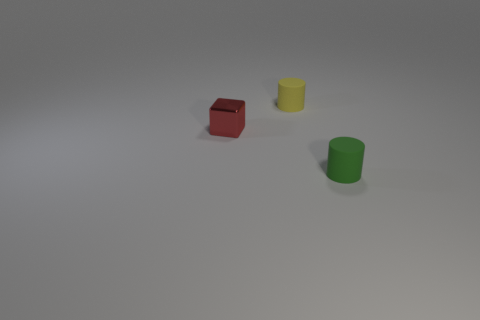Subtract all green cylinders. How many cylinders are left? 1 Add 2 large purple matte things. How many objects exist? 5 Subtract all cylinders. How many objects are left? 1 Subtract 1 cylinders. How many cylinders are left? 1 Subtract all purple blocks. Subtract all green spheres. How many blocks are left? 1 Subtract all cyan spheres. How many blue cubes are left? 0 Subtract all tiny cylinders. Subtract all red metal things. How many objects are left? 0 Add 1 small red objects. How many small red objects are left? 2 Add 3 brown metal things. How many brown metal things exist? 3 Subtract 0 red cylinders. How many objects are left? 3 